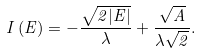<formula> <loc_0><loc_0><loc_500><loc_500>I \left ( E \right ) = - \frac { \sqrt { 2 | E | } } { \lambda } + \frac { \sqrt { A } } { \lambda \sqrt { 2 } } .</formula> 